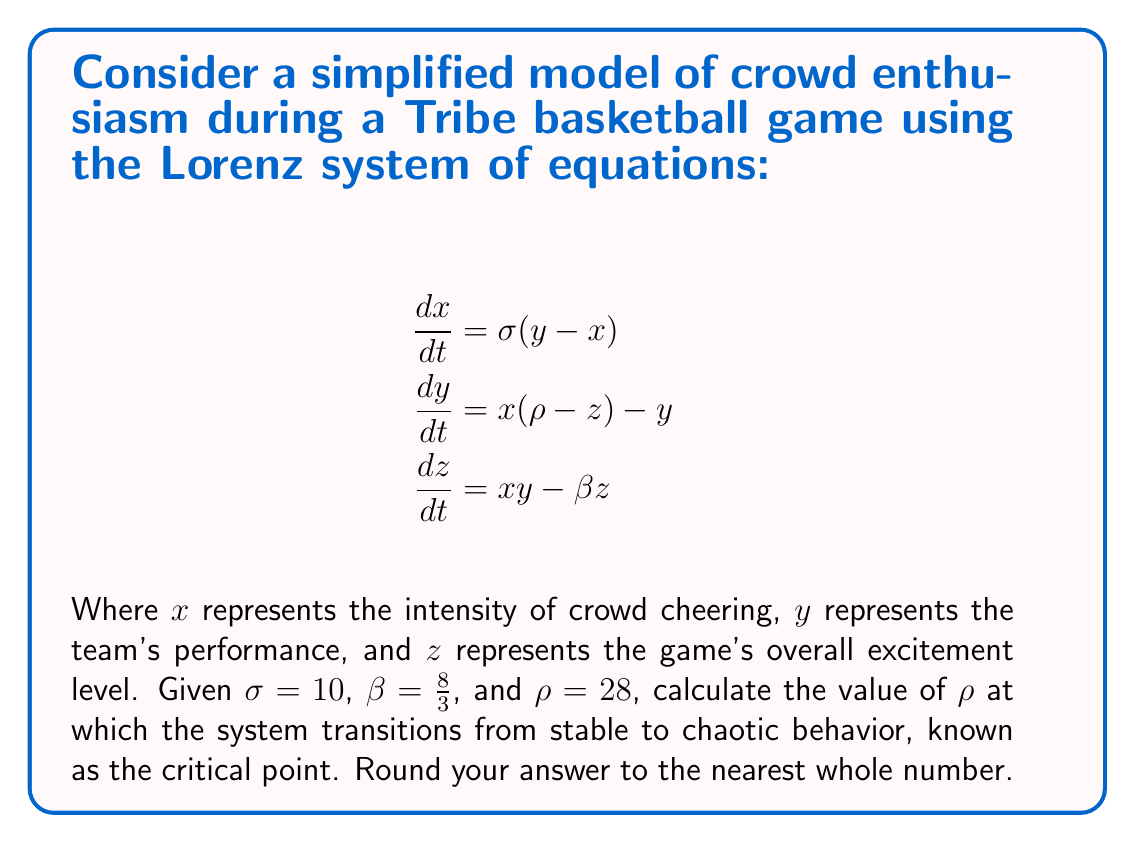Give your solution to this math problem. To find the critical point where the Lorenz system transitions from stable to chaotic behavior, we need to follow these steps:

1) In the Lorenz system, the critical point occurs when the system undergoes a Hopf bifurcation. This happens when the real parts of the complex conjugate eigenvalues of the system's Jacobian matrix cross the imaginary axis.

2) The Jacobian matrix for the Lorenz system is:

   $$J = \begin{bmatrix}
   -\sigma & \sigma & 0 \\
   \rho-z & -1 & -x \\
   y & x & -\beta
   \end{bmatrix}$$

3) At the critical point, the system has a non-trivial equilibrium point. This occurs when:

   $$x = y = \pm\sqrt{\beta(\rho-1)}$$
   $$z = \rho - 1$$

4) Substituting these values into the Jacobian and calculating its eigenvalues, we find that the Hopf bifurcation occurs when:

   $$\rho_c = \sigma\frac{\sigma+\beta+3}{\sigma-\beta-1}$$

5) Substituting the given values $\sigma = 10$ and $\beta = \frac{8}{3}$, we get:

   $$\rho_c = 10\frac{10+\frac{8}{3}+3}{10-\frac{8}{3}-1} = 10\frac{37/3}{19/3} = \frac{370}{19} \approx 19.47$$

6) Rounding to the nearest whole number, we get 19.

This critical point represents the transition from stable to chaotic behavior in crowd enthusiasm during the Tribe basketball game, where small changes in initial conditions can lead to vastly different outcomes in crowd response and game excitement.
Answer: 19 